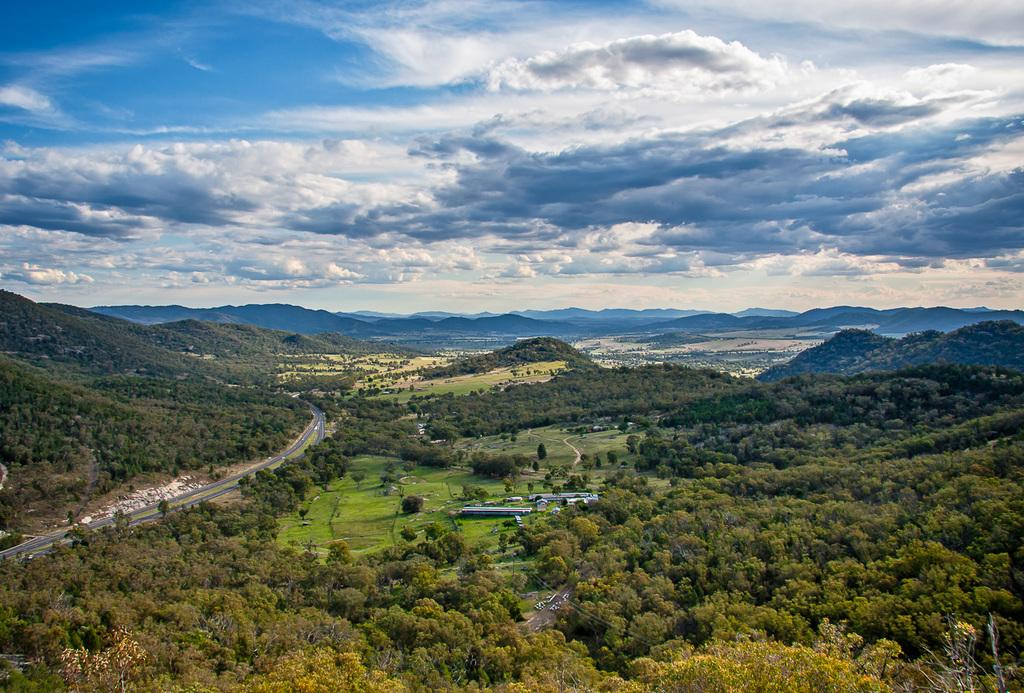What is the main feature of the image? There is a road in the image. What can be seen in the distance behind the road? There are trees, objects, and mountains in the background of the image. How would you describe the sky in the image? The sky is cloudy in the image. How many birds are perched on the trees in the image? There are no birds visible in the image; only trees, objects, and mountains can be seen in the background. Are there any bears visible in the image? There are no bears present in the image. 